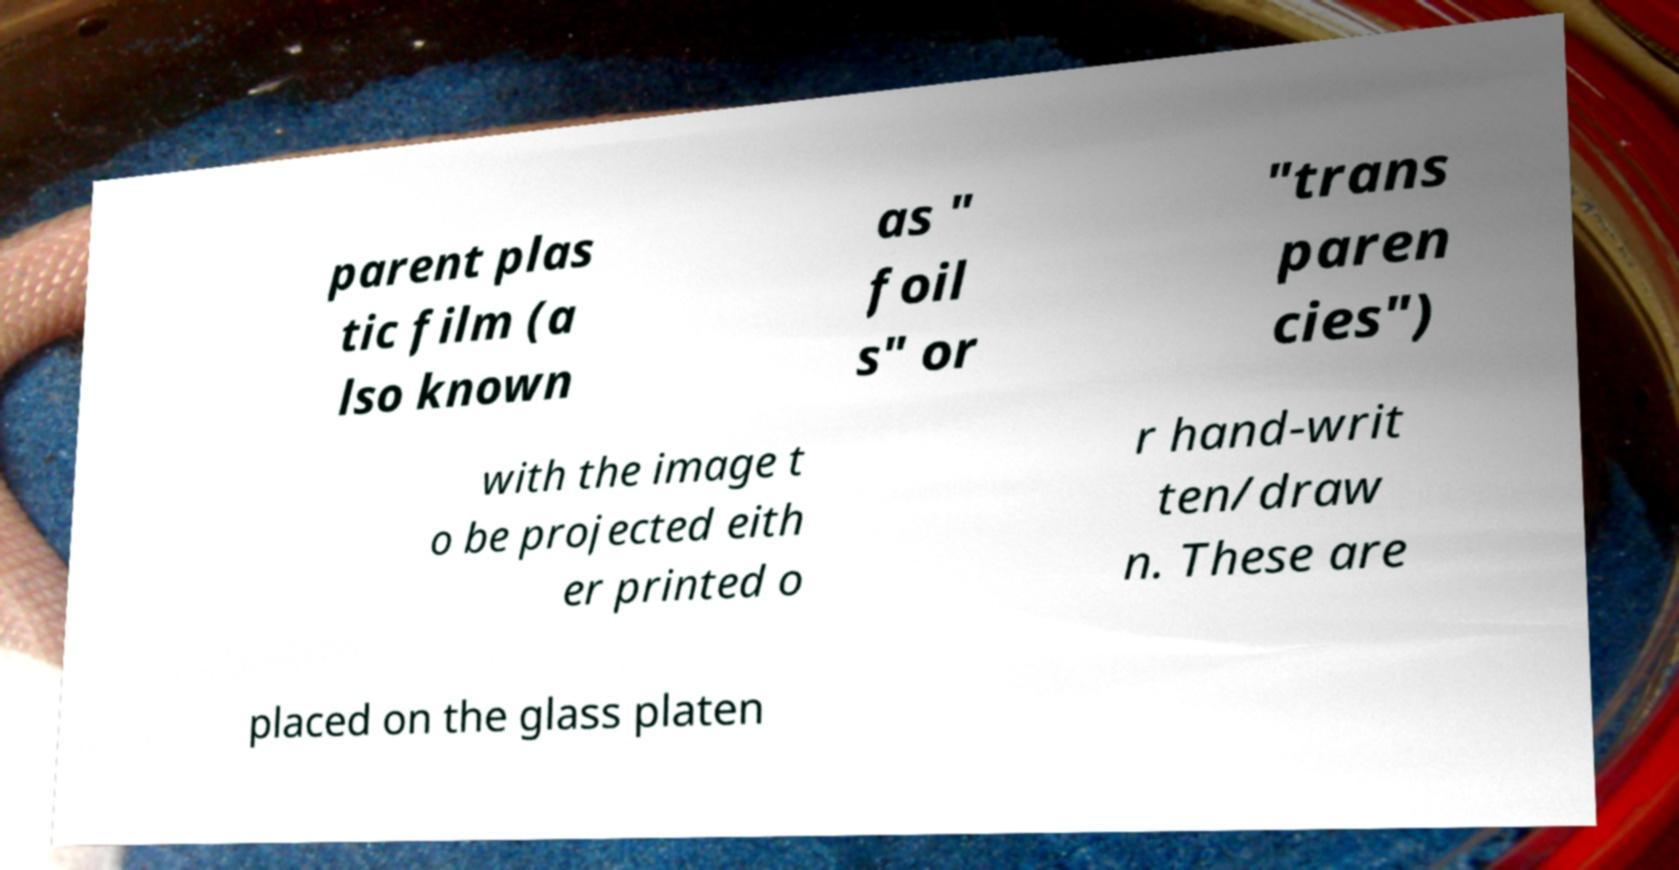There's text embedded in this image that I need extracted. Can you transcribe it verbatim? parent plas tic film (a lso known as " foil s" or "trans paren cies") with the image t o be projected eith er printed o r hand-writ ten/draw n. These are placed on the glass platen 